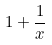Convert formula to latex. <formula><loc_0><loc_0><loc_500><loc_500>1 + \frac { 1 } { x }</formula> 